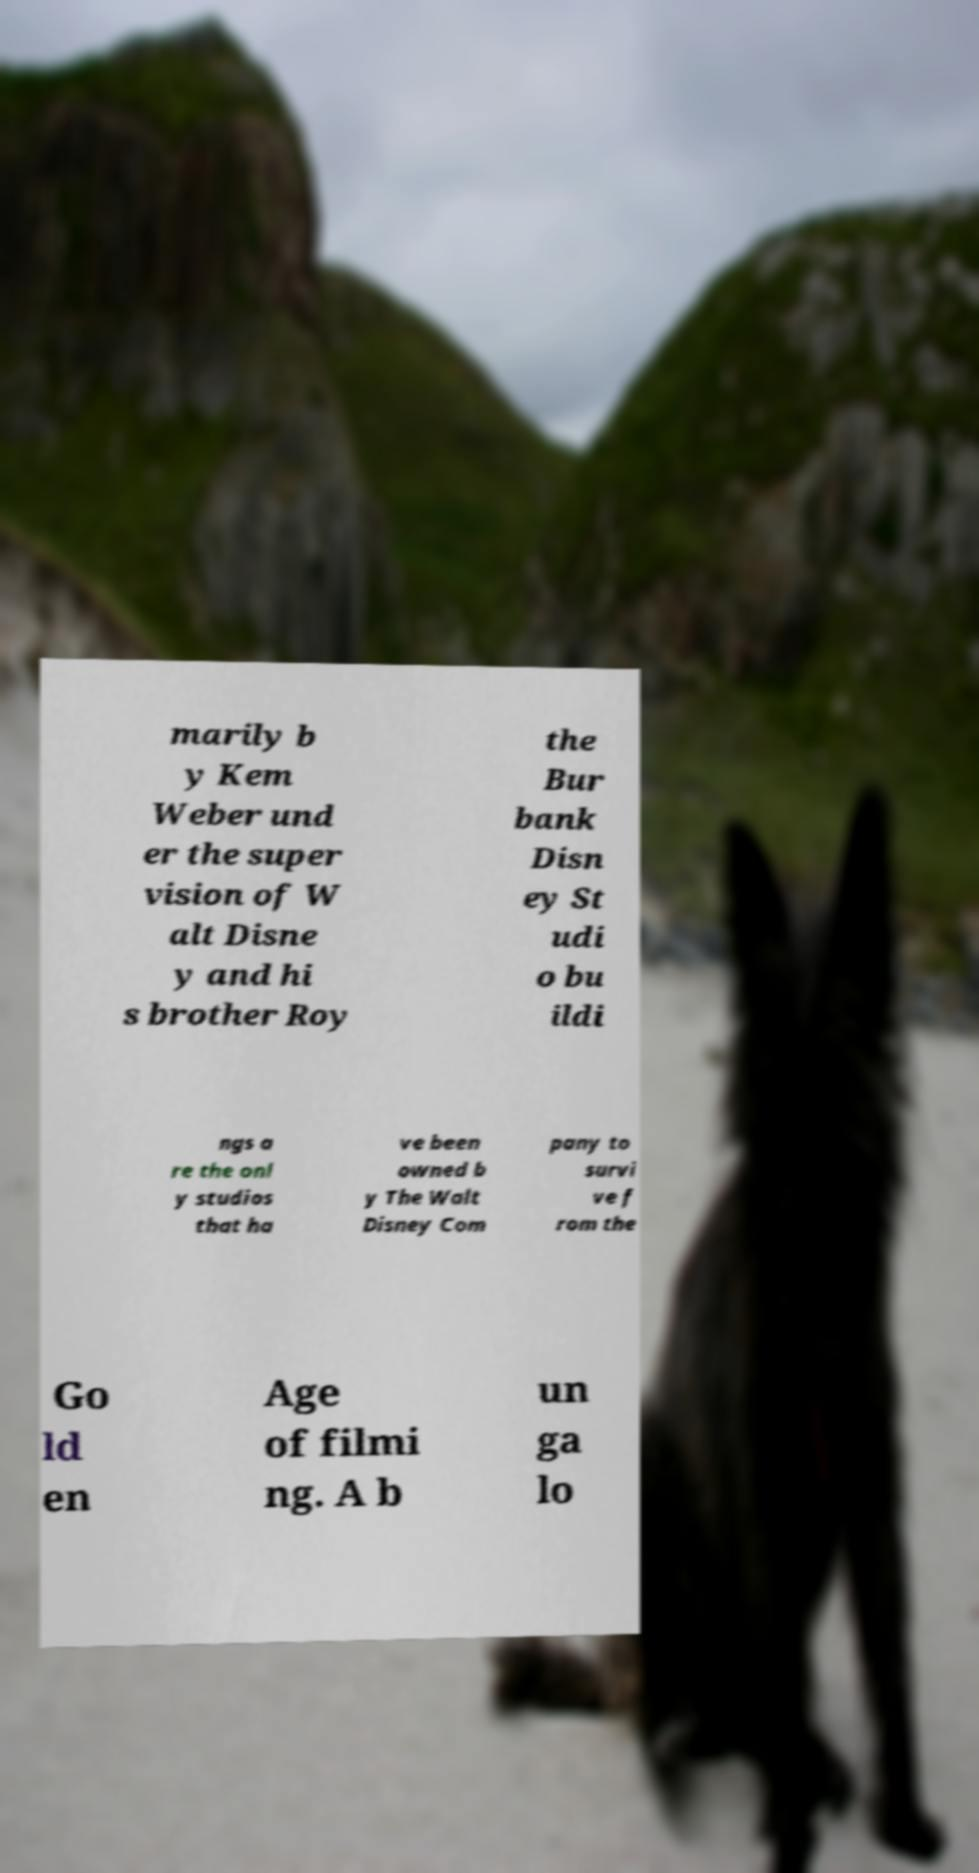What messages or text are displayed in this image? I need them in a readable, typed format. marily b y Kem Weber und er the super vision of W alt Disne y and hi s brother Roy the Bur bank Disn ey St udi o bu ildi ngs a re the onl y studios that ha ve been owned b y The Walt Disney Com pany to survi ve f rom the Go ld en Age of filmi ng. A b un ga lo 